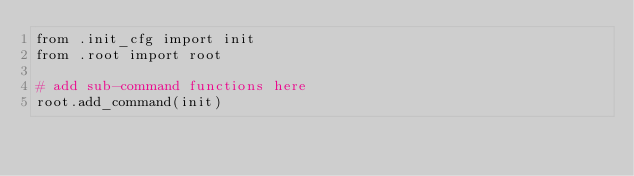Convert code to text. <code><loc_0><loc_0><loc_500><loc_500><_Python_>from .init_cfg import init
from .root import root

# add sub-command functions here
root.add_command(init)
</code> 